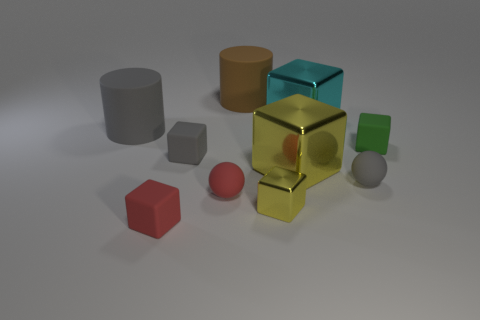Is the ball that is on the left side of the brown object made of the same material as the yellow cube that is behind the red sphere?
Provide a short and direct response. No. What material is the red ball?
Offer a very short reply. Rubber. Are there more large gray matte things that are behind the red rubber ball than small purple rubber things?
Keep it short and to the point. Yes. How many cyan objects are to the right of the ball left of the yellow shiny cube behind the tiny yellow shiny cube?
Your response must be concise. 1. What is the material of the tiny cube that is both in front of the large yellow metal cube and on the right side of the red matte block?
Offer a terse response. Metal. The small metal block has what color?
Give a very brief answer. Yellow. Is the number of metal things in front of the gray cylinder greater than the number of small rubber spheres that are to the left of the large cyan block?
Your response must be concise. Yes. What color is the large metallic block that is behind the large gray cylinder?
Your answer should be compact. Cyan. There is a matte ball that is on the right side of the cyan shiny block; is its size the same as the matte cylinder that is behind the gray cylinder?
Keep it short and to the point. No. What number of things are large cylinders or tiny brown shiny balls?
Offer a terse response. 2. 